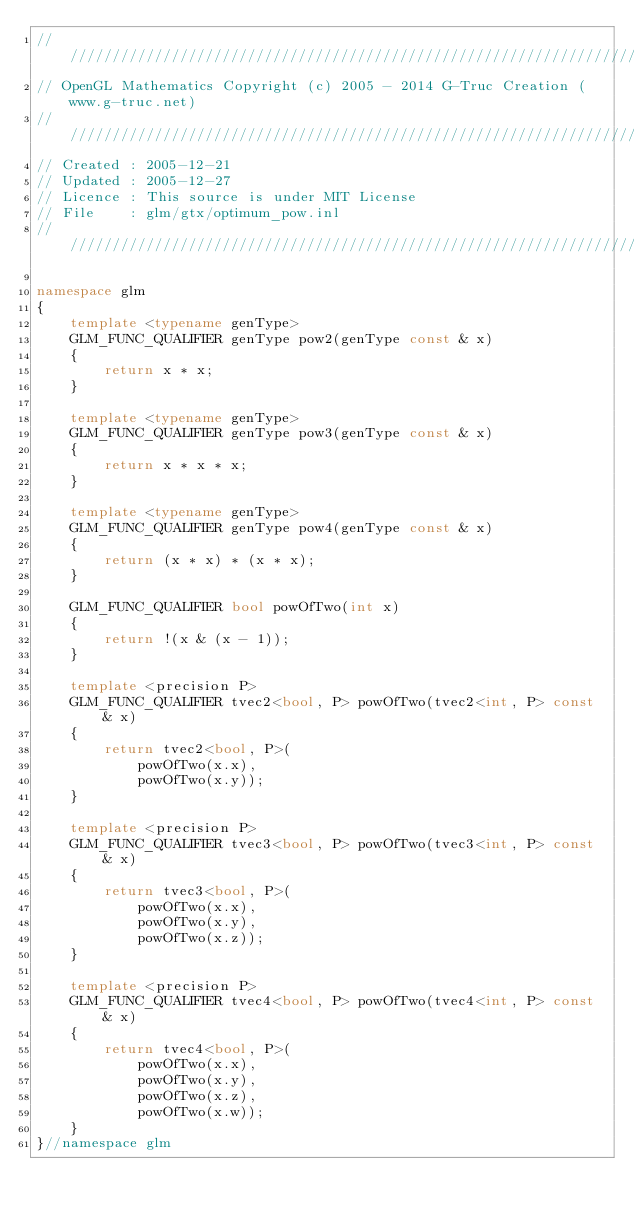<code> <loc_0><loc_0><loc_500><loc_500><_C++_>///////////////////////////////////////////////////////////////////////////////////////////////////
// OpenGL Mathematics Copyright (c) 2005 - 2014 G-Truc Creation (www.g-truc.net)
///////////////////////////////////////////////////////////////////////////////////////////////////
// Created : 2005-12-21
// Updated : 2005-12-27
// Licence : This source is under MIT License
// File    : glm/gtx/optimum_pow.inl
///////////////////////////////////////////////////////////////////////////////////////////////////

namespace glm
{
	template <typename genType>
	GLM_FUNC_QUALIFIER genType pow2(genType const & x)
	{
		return x * x;
	}

	template <typename genType>
	GLM_FUNC_QUALIFIER genType pow3(genType const & x)
	{
		return x * x * x;
	}

	template <typename genType>
	GLM_FUNC_QUALIFIER genType pow4(genType const & x)
	{
		return (x * x) * (x * x);
	}

	GLM_FUNC_QUALIFIER bool powOfTwo(int x)
	{
		return !(x & (x - 1));
	}

	template <precision P>
	GLM_FUNC_QUALIFIER tvec2<bool, P> powOfTwo(tvec2<int, P> const & x)
	{
		return tvec2<bool, P>(
			powOfTwo(x.x),
			powOfTwo(x.y));
	}

	template <precision P>
	GLM_FUNC_QUALIFIER tvec3<bool, P> powOfTwo(tvec3<int, P> const & x)
	{
		return tvec3<bool, P>(
			powOfTwo(x.x),
			powOfTwo(x.y),
			powOfTwo(x.z));
	}

	template <precision P>
	GLM_FUNC_QUALIFIER tvec4<bool, P> powOfTwo(tvec4<int, P> const & x)
	{
		return tvec4<bool, P>(
			powOfTwo(x.x),
			powOfTwo(x.y),
			powOfTwo(x.z),
			powOfTwo(x.w));
	}
}//namespace glm
</code> 